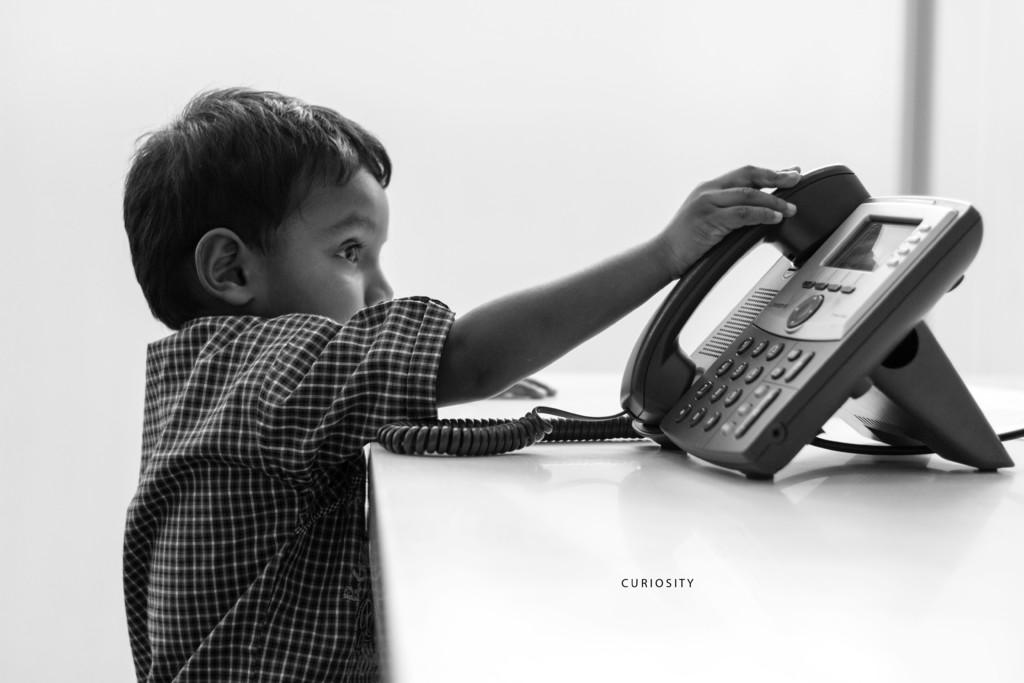Who is in the picture? There is a boy in the picture. What is the boy doing in the picture? The boy is standing. What is the boy holding in the picture? The boy is holding a telephone handset. What else can be seen on the table in the picture? There is a telephone and a cable on the table. What can be read in the image? There is text visible in the image. What is the color of the background in the image? The background of the image is white. What type of smell can be detected from the boy in the image? There is no information about smells in the image, so it cannot be determined. 